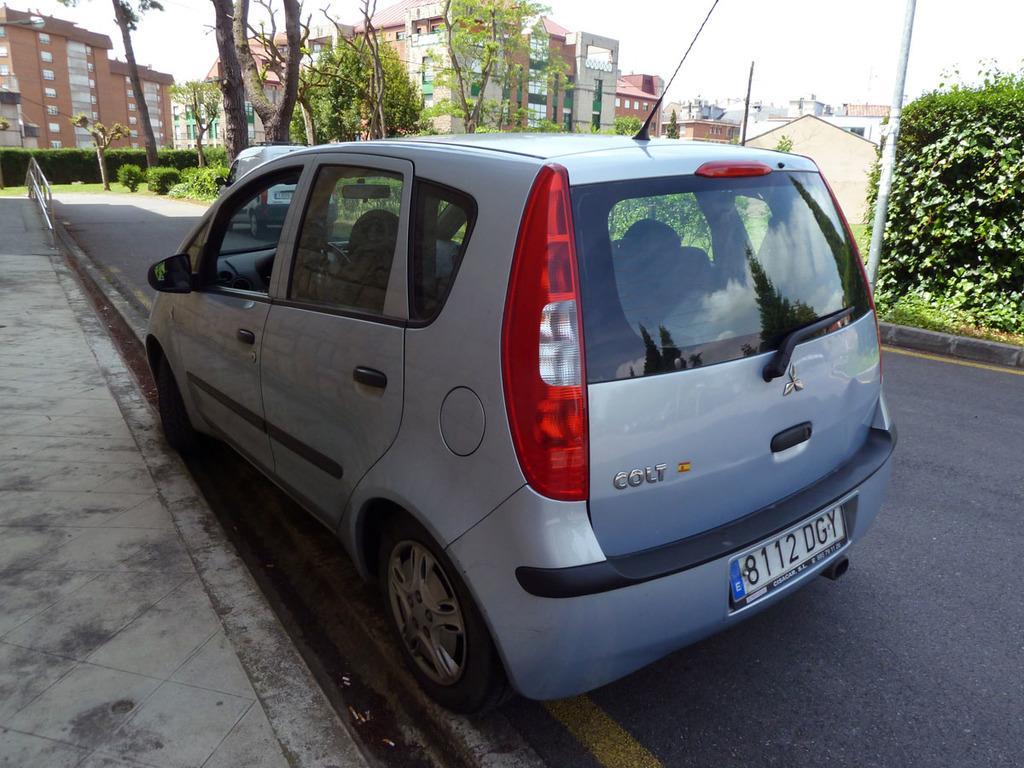Can you describe this image briefly? In this image we can see buildings, motor vehicles on the road, trees, poles and sky. 